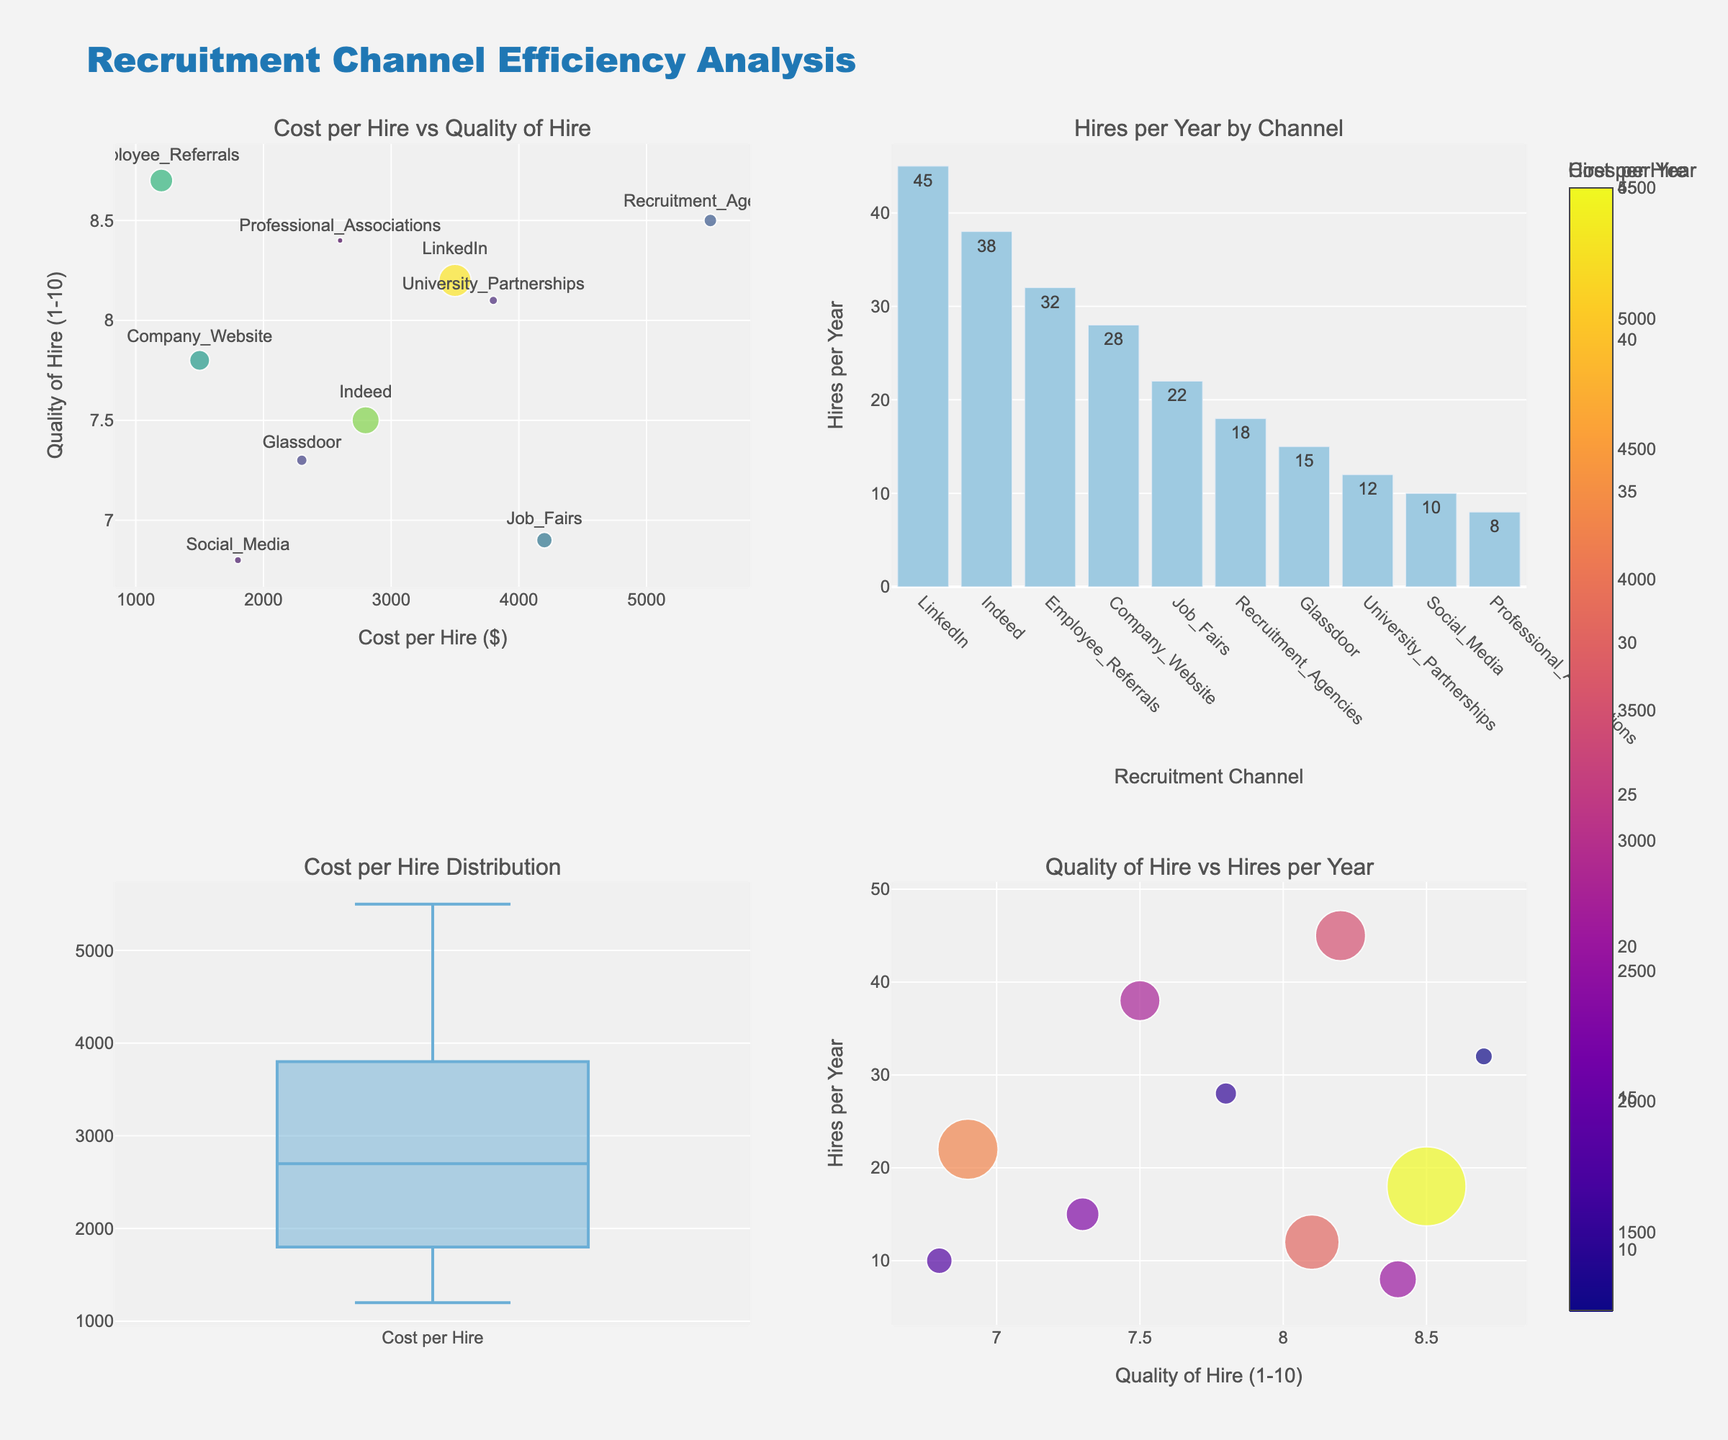Which recruitment channel has the highest cost per hire? The scatter plot on the top-left visually shows that "Recruitment Agencies" is located at the farthest right end, indicating the highest cost per hire.
Answer: Recruitment Agencies How many hires per year are made through LinkedIn? The bar chart on the top-right displays the number of hires per year, where LinkedIn has a value of 45 on the y-axis.
Answer: 45 Which recruitment channel has the lowest quality of hire? The scatter plot on the bottom-right indicates that "Social Media" has the lowest value on the y-axis for quality of hire.
Answer: Social Media What is the distribution of cost per hire across recruitment channels? The box plot on the bottom-left summarizes the spread of the cost per hire, showing its median value and variability.
Answer: Range: $1200 to $5500 What is the median cost per hire? The box plot on the bottom-left shows the median line, it appears to be slightly above $3000.
Answer: ~$3200 Which recruitment channel has the highest quality of hire? The scatter plot on the top-left shows "Employee Referrals" with the highest y-value for quality of hire.
Answer: Employee Referrals How much is the quality of hire for Job Fairs compared to University Partnerships? The scatter plot on the top-left and bottom-right show Job Fairs having a quality of hire of 6.9 and University Partnerships having 8.1, comparing the two values.
Answer: Job Fairs: 6.9, University Partnerships: 8.1 What is the relationship between cost per hire and quality of hire? The scatter plot on the top-left visualizes a slightly positive correlation between cost per hire and quality of hire, with dots generally increasing in y-axis as they go to the right on the x-axis.
Answer: Positive correlation How does the number of hires per year influence the cost per hire? The scatter plot on the bottom-right shows the relation; larger bubbles indicate higher hires per year and are generally associated with lower costs per hire.
Answer: Higher hires, typically lower cost Which recruitment channel offers the best balance of cost per hire and quality of hire? The scatter plot on the top-left and their relative positions show "Employee Referrals" as offering a low cost per hire and high quality of hire combination.
Answer: Employee Referrals 